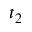<formula> <loc_0><loc_0><loc_500><loc_500>t _ { 2 }</formula> 